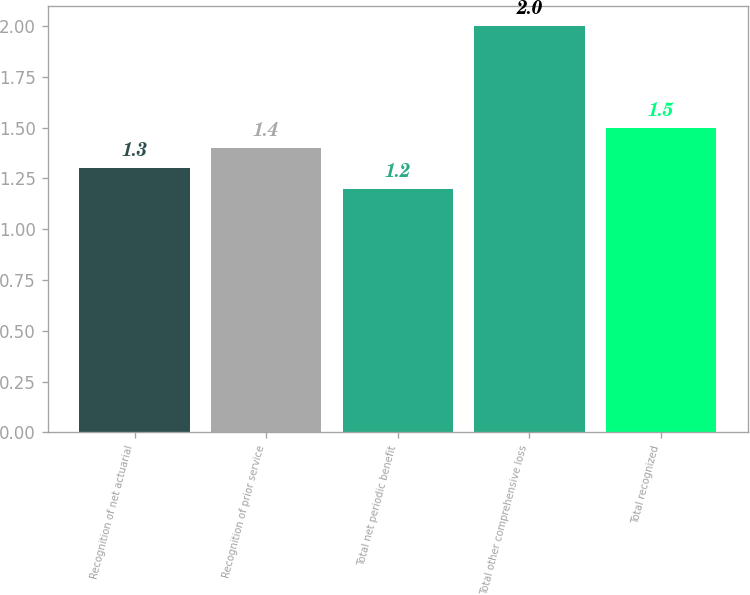Convert chart to OTSL. <chart><loc_0><loc_0><loc_500><loc_500><bar_chart><fcel>Recognition of net actuarial<fcel>Recognition of prior service<fcel>Total net periodic benefit<fcel>Total other comprehensive loss<fcel>Total recognized<nl><fcel>1.3<fcel>1.4<fcel>1.2<fcel>2<fcel>1.5<nl></chart> 